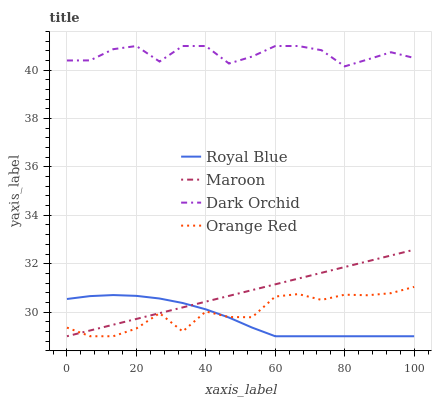Does Royal Blue have the minimum area under the curve?
Answer yes or no. Yes. Does Dark Orchid have the maximum area under the curve?
Answer yes or no. Yes. Does Maroon have the minimum area under the curve?
Answer yes or no. No. Does Maroon have the maximum area under the curve?
Answer yes or no. No. Is Maroon the smoothest?
Answer yes or no. Yes. Is Orange Red the roughest?
Answer yes or no. Yes. Is Dark Orchid the smoothest?
Answer yes or no. No. Is Dark Orchid the roughest?
Answer yes or no. No. Does Royal Blue have the lowest value?
Answer yes or no. Yes. Does Dark Orchid have the lowest value?
Answer yes or no. No. Does Dark Orchid have the highest value?
Answer yes or no. Yes. Does Maroon have the highest value?
Answer yes or no. No. Is Royal Blue less than Dark Orchid?
Answer yes or no. Yes. Is Dark Orchid greater than Maroon?
Answer yes or no. Yes. Does Maroon intersect Orange Red?
Answer yes or no. Yes. Is Maroon less than Orange Red?
Answer yes or no. No. Is Maroon greater than Orange Red?
Answer yes or no. No. Does Royal Blue intersect Dark Orchid?
Answer yes or no. No. 